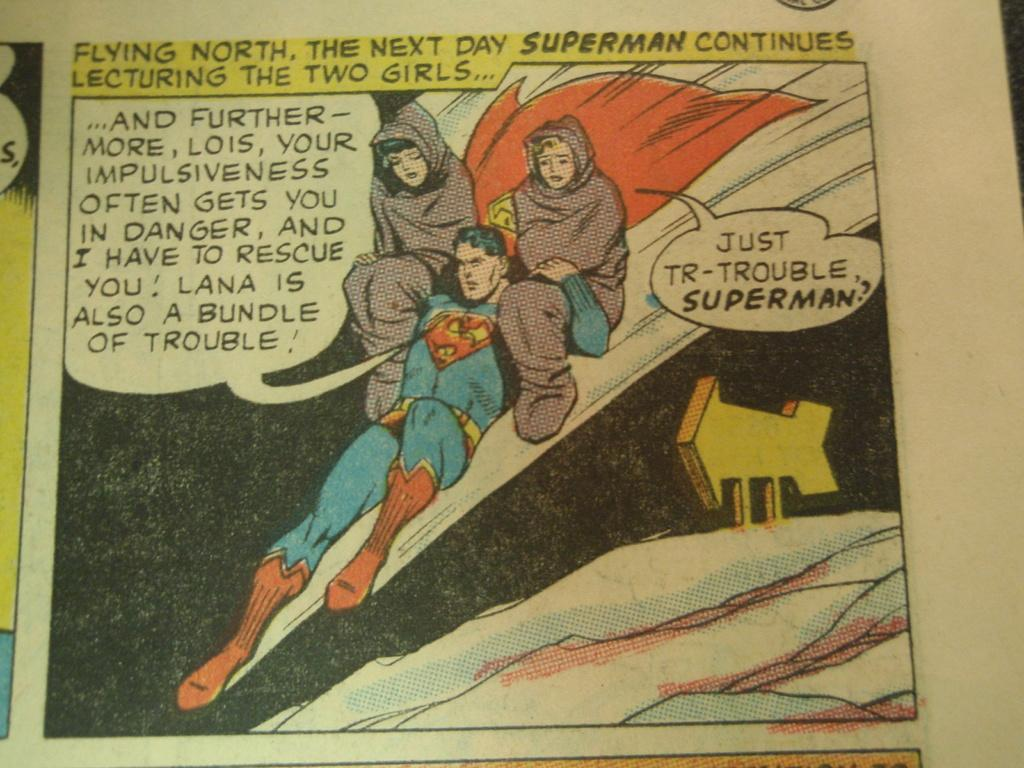Provide a one-sentence caption for the provided image. A comic strip shows Superman lecturing Lois and Lana. 